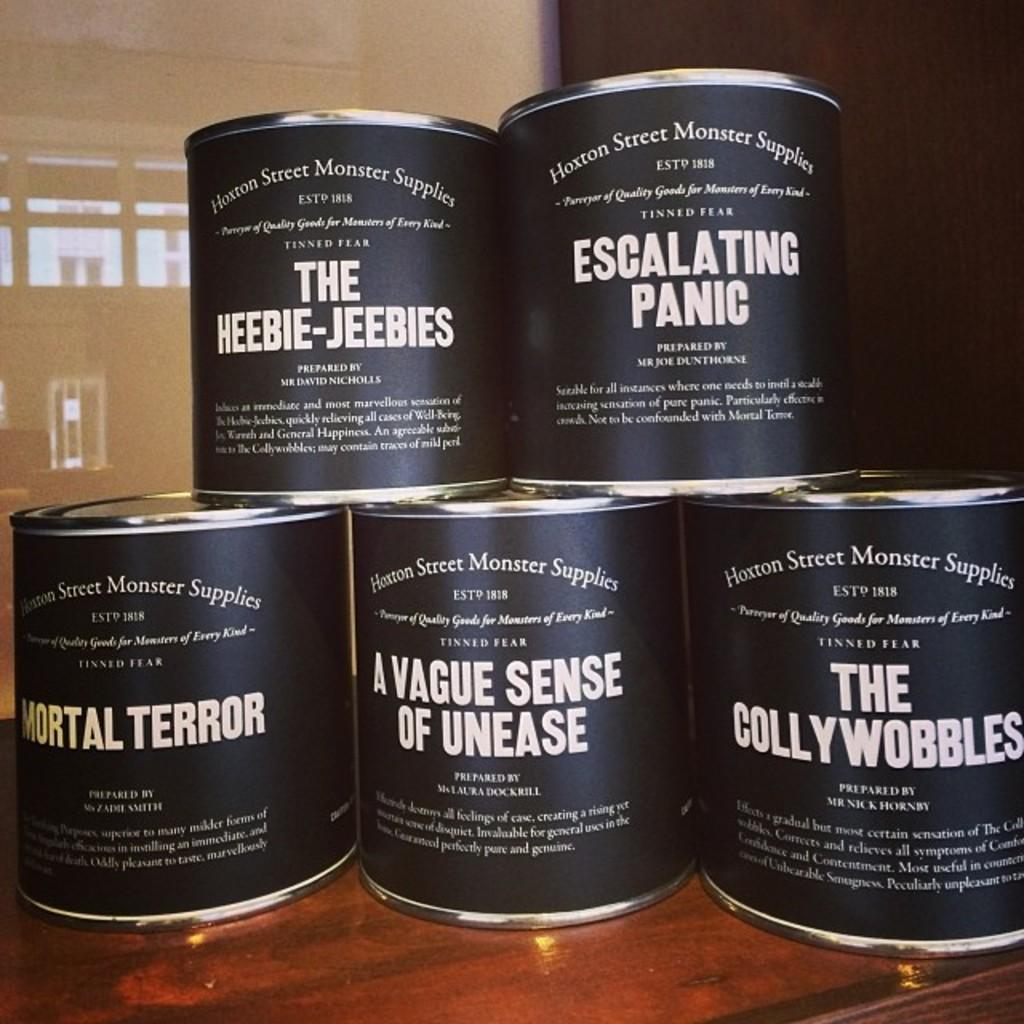How many tins are visible in the image? There are five tins in the image. What can be found on the tins? There is printed text on the tins. What type of surface is at the bottom of the image? There is a wooden surface at the bottom of the image. What type of request can be seen written on the tins? There is no request visible on the tins; they only have printed text. What type of alarm is present in the image? There is no alarm present in the image; it only features five tins and a wooden surface. 